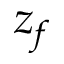Convert formula to latex. <formula><loc_0><loc_0><loc_500><loc_500>z _ { f }</formula> 